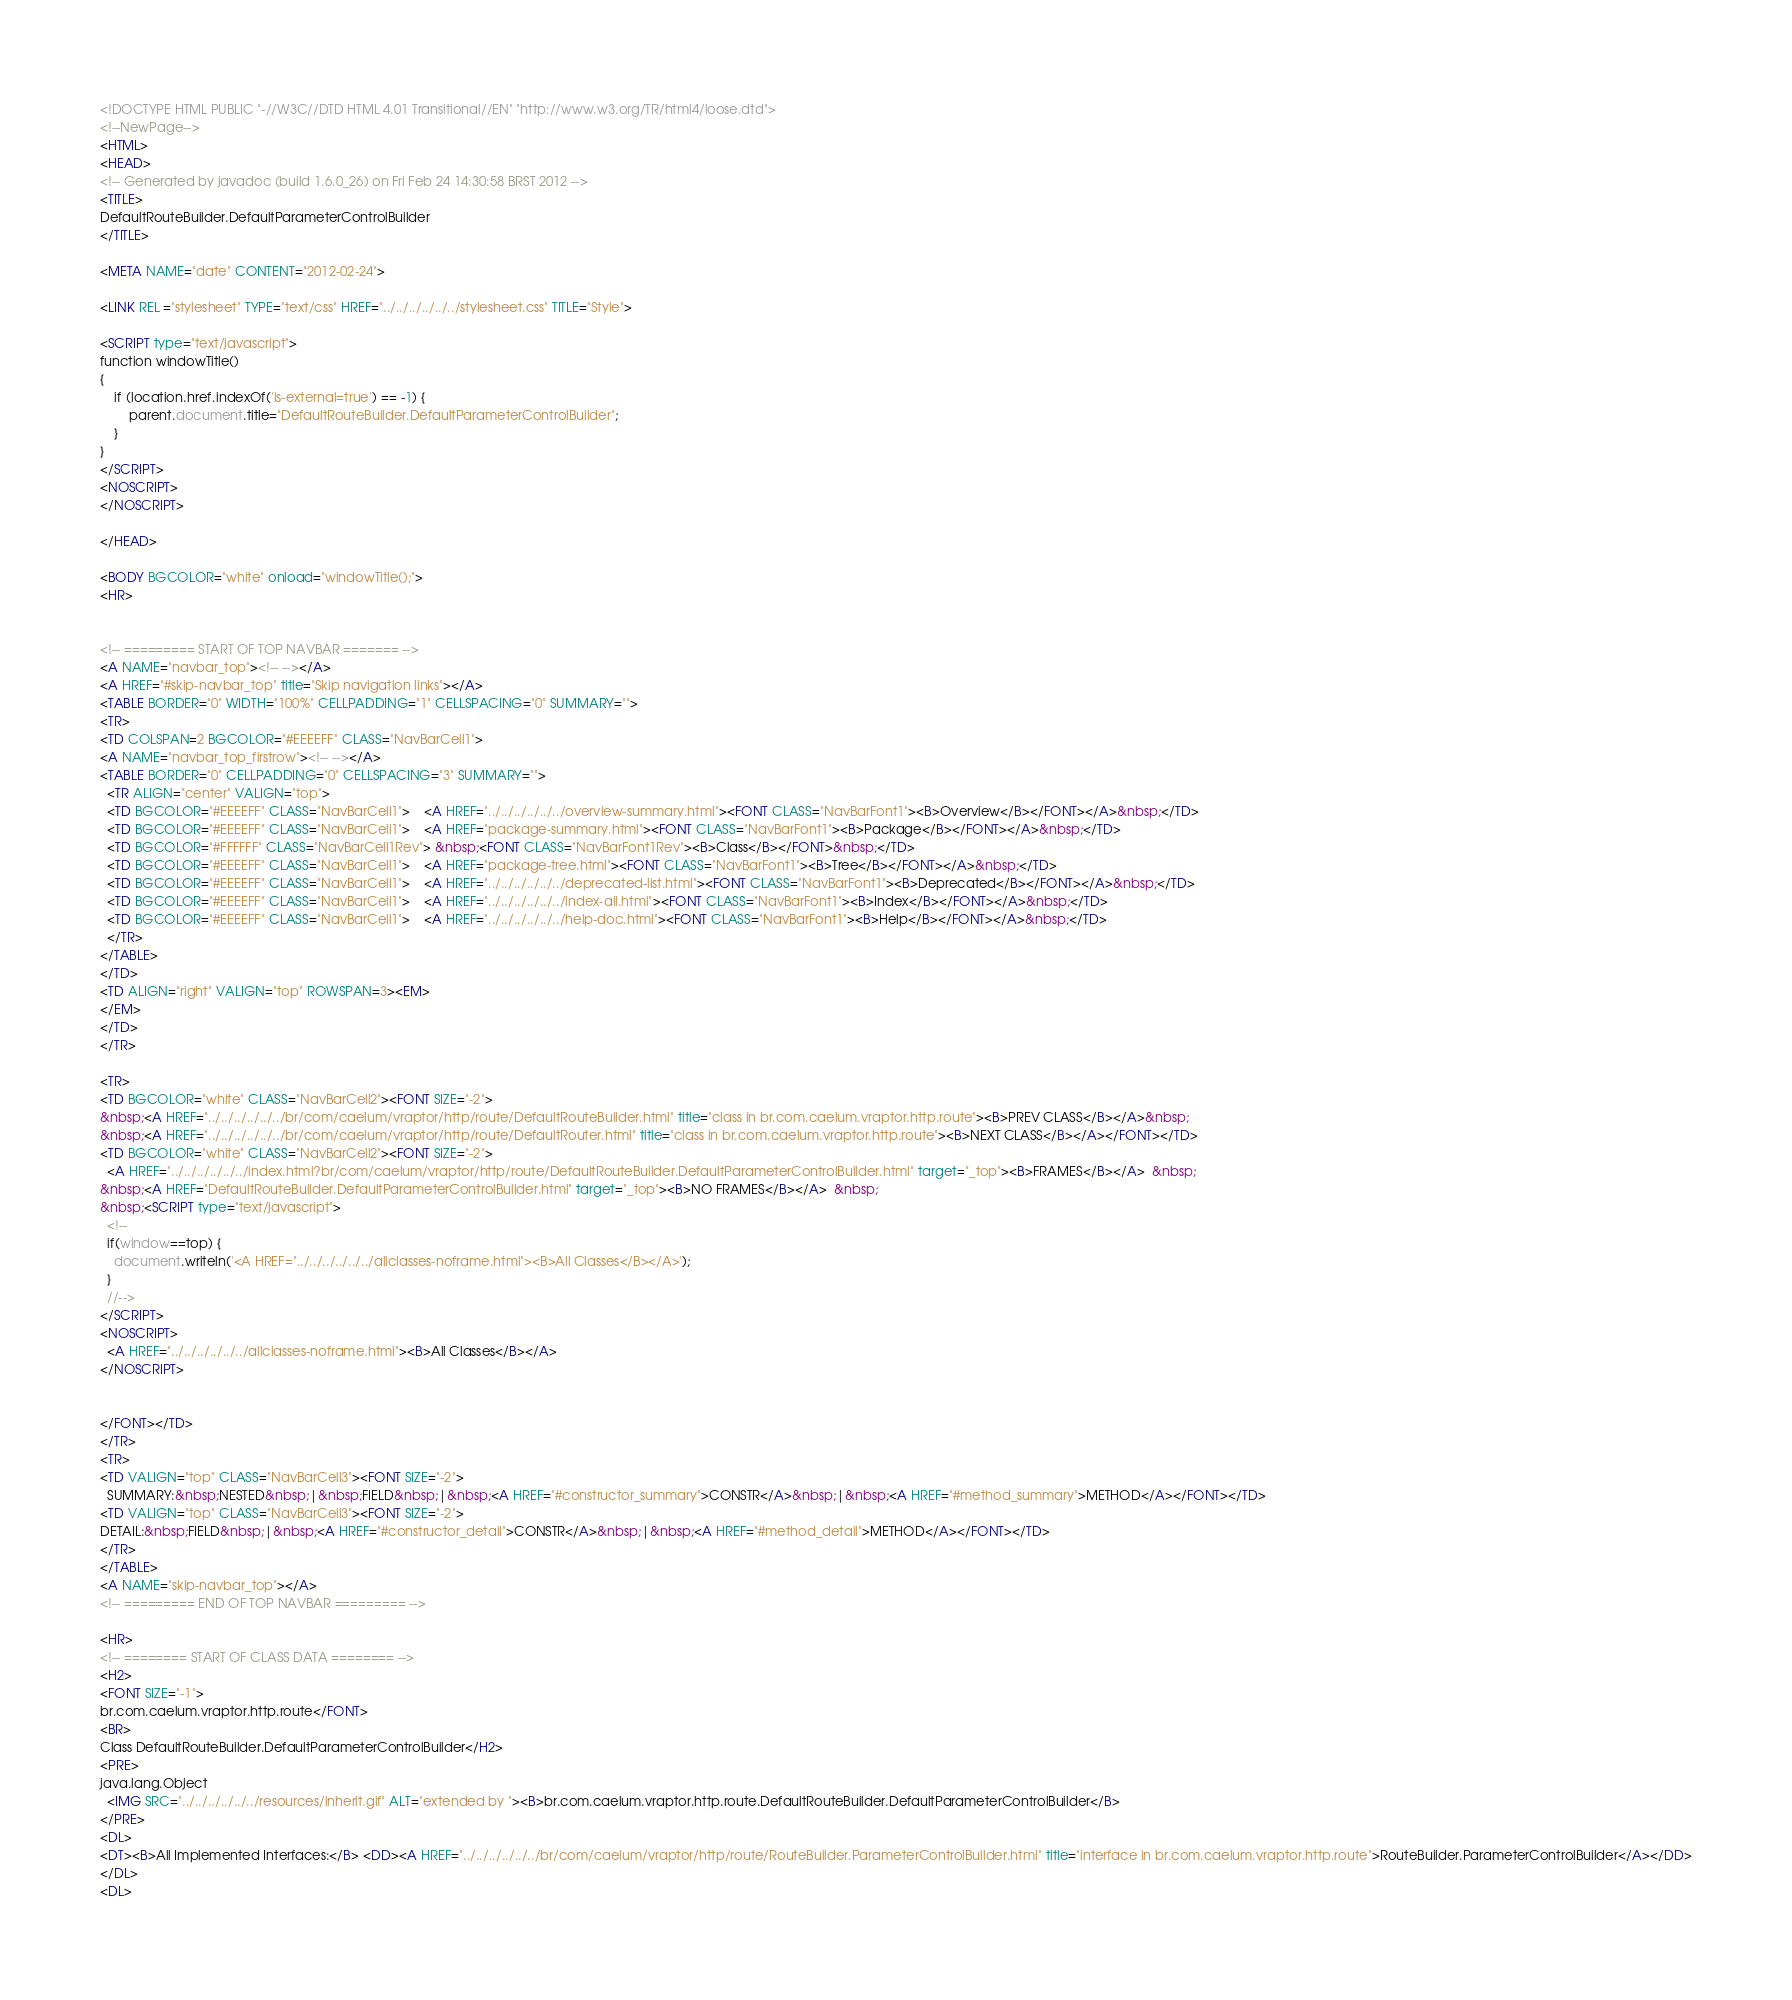<code> <loc_0><loc_0><loc_500><loc_500><_HTML_><!DOCTYPE HTML PUBLIC "-//W3C//DTD HTML 4.01 Transitional//EN" "http://www.w3.org/TR/html4/loose.dtd">
<!--NewPage-->
<HTML>
<HEAD>
<!-- Generated by javadoc (build 1.6.0_26) on Fri Feb 24 14:30:58 BRST 2012 -->
<TITLE>
DefaultRouteBuilder.DefaultParameterControlBuilder
</TITLE>

<META NAME="date" CONTENT="2012-02-24">

<LINK REL ="stylesheet" TYPE="text/css" HREF="../../../../../../stylesheet.css" TITLE="Style">

<SCRIPT type="text/javascript">
function windowTitle()
{
    if (location.href.indexOf('is-external=true') == -1) {
        parent.document.title="DefaultRouteBuilder.DefaultParameterControlBuilder";
    }
}
</SCRIPT>
<NOSCRIPT>
</NOSCRIPT>

</HEAD>

<BODY BGCOLOR="white" onload="windowTitle();">
<HR>


<!-- ========= START OF TOP NAVBAR ======= -->
<A NAME="navbar_top"><!-- --></A>
<A HREF="#skip-navbar_top" title="Skip navigation links"></A>
<TABLE BORDER="0" WIDTH="100%" CELLPADDING="1" CELLSPACING="0" SUMMARY="">
<TR>
<TD COLSPAN=2 BGCOLOR="#EEEEFF" CLASS="NavBarCell1">
<A NAME="navbar_top_firstrow"><!-- --></A>
<TABLE BORDER="0" CELLPADDING="0" CELLSPACING="3" SUMMARY="">
  <TR ALIGN="center" VALIGN="top">
  <TD BGCOLOR="#EEEEFF" CLASS="NavBarCell1">    <A HREF="../../../../../../overview-summary.html"><FONT CLASS="NavBarFont1"><B>Overview</B></FONT></A>&nbsp;</TD>
  <TD BGCOLOR="#EEEEFF" CLASS="NavBarCell1">    <A HREF="package-summary.html"><FONT CLASS="NavBarFont1"><B>Package</B></FONT></A>&nbsp;</TD>
  <TD BGCOLOR="#FFFFFF" CLASS="NavBarCell1Rev"> &nbsp;<FONT CLASS="NavBarFont1Rev"><B>Class</B></FONT>&nbsp;</TD>
  <TD BGCOLOR="#EEEEFF" CLASS="NavBarCell1">    <A HREF="package-tree.html"><FONT CLASS="NavBarFont1"><B>Tree</B></FONT></A>&nbsp;</TD>
  <TD BGCOLOR="#EEEEFF" CLASS="NavBarCell1">    <A HREF="../../../../../../deprecated-list.html"><FONT CLASS="NavBarFont1"><B>Deprecated</B></FONT></A>&nbsp;</TD>
  <TD BGCOLOR="#EEEEFF" CLASS="NavBarCell1">    <A HREF="../../../../../../index-all.html"><FONT CLASS="NavBarFont1"><B>Index</B></FONT></A>&nbsp;</TD>
  <TD BGCOLOR="#EEEEFF" CLASS="NavBarCell1">    <A HREF="../../../../../../help-doc.html"><FONT CLASS="NavBarFont1"><B>Help</B></FONT></A>&nbsp;</TD>
  </TR>
</TABLE>
</TD>
<TD ALIGN="right" VALIGN="top" ROWSPAN=3><EM>
</EM>
</TD>
</TR>

<TR>
<TD BGCOLOR="white" CLASS="NavBarCell2"><FONT SIZE="-2">
&nbsp;<A HREF="../../../../../../br/com/caelum/vraptor/http/route/DefaultRouteBuilder.html" title="class in br.com.caelum.vraptor.http.route"><B>PREV CLASS</B></A>&nbsp;
&nbsp;<A HREF="../../../../../../br/com/caelum/vraptor/http/route/DefaultRouter.html" title="class in br.com.caelum.vraptor.http.route"><B>NEXT CLASS</B></A></FONT></TD>
<TD BGCOLOR="white" CLASS="NavBarCell2"><FONT SIZE="-2">
  <A HREF="../../../../../../index.html?br/com/caelum/vraptor/http/route/DefaultRouteBuilder.DefaultParameterControlBuilder.html" target="_top"><B>FRAMES</B></A>  &nbsp;
&nbsp;<A HREF="DefaultRouteBuilder.DefaultParameterControlBuilder.html" target="_top"><B>NO FRAMES</B></A>  &nbsp;
&nbsp;<SCRIPT type="text/javascript">
  <!--
  if(window==top) {
    document.writeln('<A HREF="../../../../../../allclasses-noframe.html"><B>All Classes</B></A>');
  }
  //-->
</SCRIPT>
<NOSCRIPT>
  <A HREF="../../../../../../allclasses-noframe.html"><B>All Classes</B></A>
</NOSCRIPT>


</FONT></TD>
</TR>
<TR>
<TD VALIGN="top" CLASS="NavBarCell3"><FONT SIZE="-2">
  SUMMARY:&nbsp;NESTED&nbsp;|&nbsp;FIELD&nbsp;|&nbsp;<A HREF="#constructor_summary">CONSTR</A>&nbsp;|&nbsp;<A HREF="#method_summary">METHOD</A></FONT></TD>
<TD VALIGN="top" CLASS="NavBarCell3"><FONT SIZE="-2">
DETAIL:&nbsp;FIELD&nbsp;|&nbsp;<A HREF="#constructor_detail">CONSTR</A>&nbsp;|&nbsp;<A HREF="#method_detail">METHOD</A></FONT></TD>
</TR>
</TABLE>
<A NAME="skip-navbar_top"></A>
<!-- ========= END OF TOP NAVBAR ========= -->

<HR>
<!-- ======== START OF CLASS DATA ======== -->
<H2>
<FONT SIZE="-1">
br.com.caelum.vraptor.http.route</FONT>
<BR>
Class DefaultRouteBuilder.DefaultParameterControlBuilder</H2>
<PRE>
java.lang.Object
  <IMG SRC="../../../../../../resources/inherit.gif" ALT="extended by "><B>br.com.caelum.vraptor.http.route.DefaultRouteBuilder.DefaultParameterControlBuilder</B>
</PRE>
<DL>
<DT><B>All Implemented Interfaces:</B> <DD><A HREF="../../../../../../br/com/caelum/vraptor/http/route/RouteBuilder.ParameterControlBuilder.html" title="interface in br.com.caelum.vraptor.http.route">RouteBuilder.ParameterControlBuilder</A></DD>
</DL>
<DL></code> 